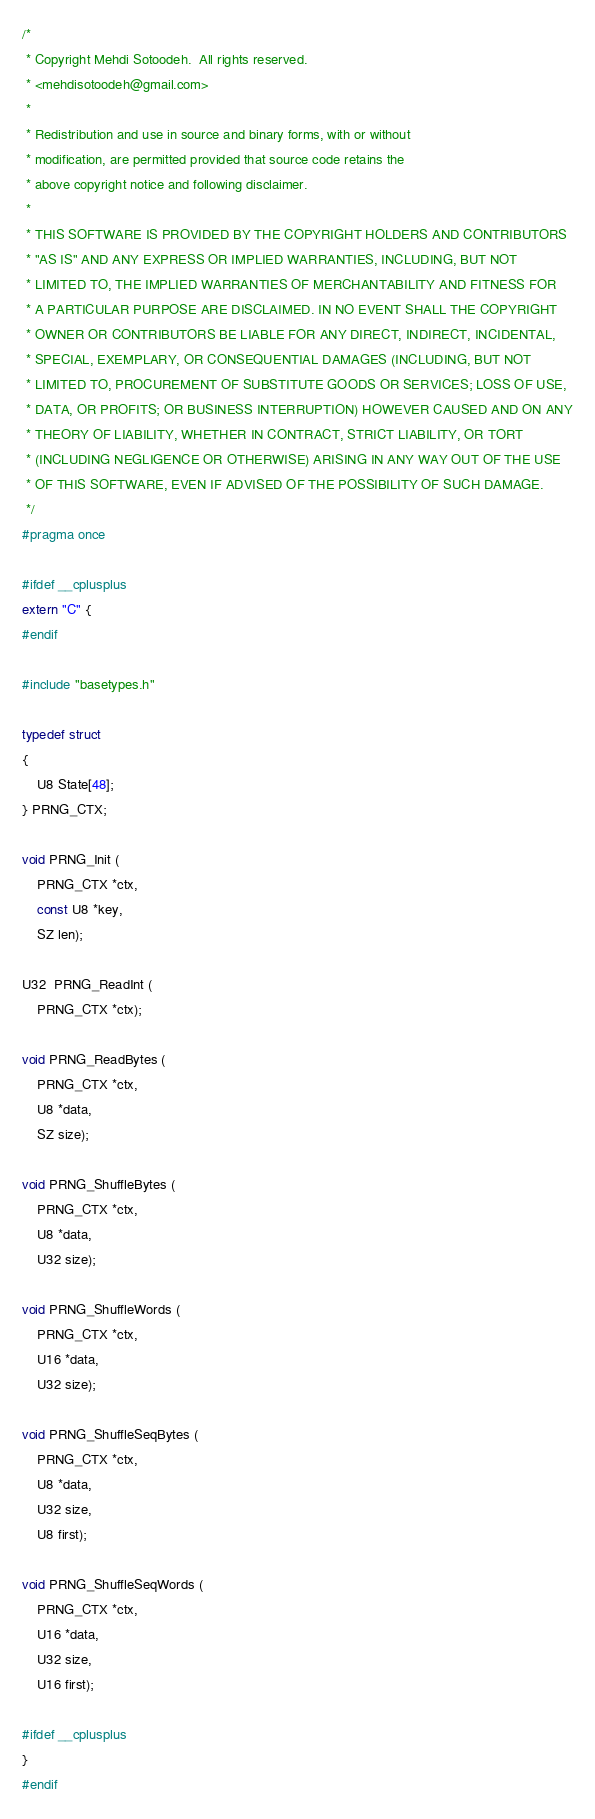Convert code to text. <code><loc_0><loc_0><loc_500><loc_500><_C_>/* 
 * Copyright Mehdi Sotoodeh.  All rights reserved. 
 * <mehdisotoodeh@gmail.com>
 *
 * Redistribution and use in source and binary forms, with or without
 * modification, are permitted provided that source code retains the 
 * above copyright notice and following disclaimer.
 *
 * THIS SOFTWARE IS PROVIDED BY THE COPYRIGHT HOLDERS AND CONTRIBUTORS
 * "AS IS" AND ANY EXPRESS OR IMPLIED WARRANTIES, INCLUDING, BUT NOT
 * LIMITED TO, THE IMPLIED WARRANTIES OF MERCHANTABILITY AND FITNESS FOR
 * A PARTICULAR PURPOSE ARE DISCLAIMED. IN NO EVENT SHALL THE COPYRIGHT
 * OWNER OR CONTRIBUTORS BE LIABLE FOR ANY DIRECT, INDIRECT, INCIDENTAL,
 * SPECIAL, EXEMPLARY, OR CONSEQUENTIAL DAMAGES (INCLUDING, BUT NOT
 * LIMITED TO, PROCUREMENT OF SUBSTITUTE GOODS OR SERVICES; LOSS OF USE,
 * DATA, OR PROFITS; OR BUSINESS INTERRUPTION) HOWEVER CAUSED AND ON ANY
 * THEORY OF LIABILITY, WHETHER IN CONTRACT, STRICT LIABILITY, OR TORT
 * (INCLUDING NEGLIGENCE OR OTHERWISE) ARISING IN ANY WAY OUT OF THE USE
 * OF THIS SOFTWARE, EVEN IF ADVISED OF THE POSSIBILITY OF SUCH DAMAGE.
 */
#pragma once

#ifdef __cplusplus
extern "C" {
#endif

#include "basetypes.h"

typedef struct
{
    U8 State[48];
} PRNG_CTX;

void PRNG_Init (
    PRNG_CTX *ctx, 
    const U8 *key, 
    SZ len);

U32  PRNG_ReadInt (
    PRNG_CTX *ctx);

void PRNG_ReadBytes (
    PRNG_CTX *ctx,
    U8 *data, 
    SZ size);

void PRNG_ShuffleBytes (
    PRNG_CTX *ctx, 
    U8 *data, 
    U32 size);

void PRNG_ShuffleWords (
    PRNG_CTX *ctx, 
    U16 *data, 
    U32 size);

void PRNG_ShuffleSeqBytes (
    PRNG_CTX *ctx, 
    U8 *data, 
    U32 size, 
    U8 first);

void PRNG_ShuffleSeqWords (
    PRNG_CTX *ctx, 
    U16 *data, 
    U32 size, 
    U16 first);

#ifdef __cplusplus
}
#endif</code> 